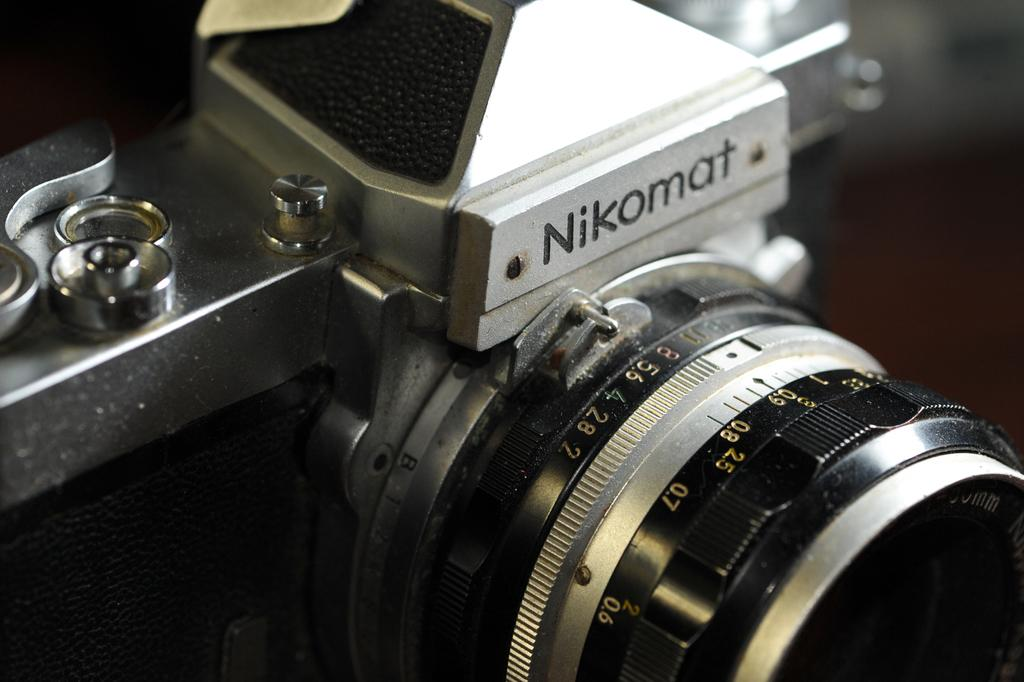What is the main object in the image? There is a camera in the image. How many bears are visible in the image? There are no bears present in the image. Are the sisters holding the camera in the image? There is no mention of sisters in the image, and the camera is not being held by anyone. 